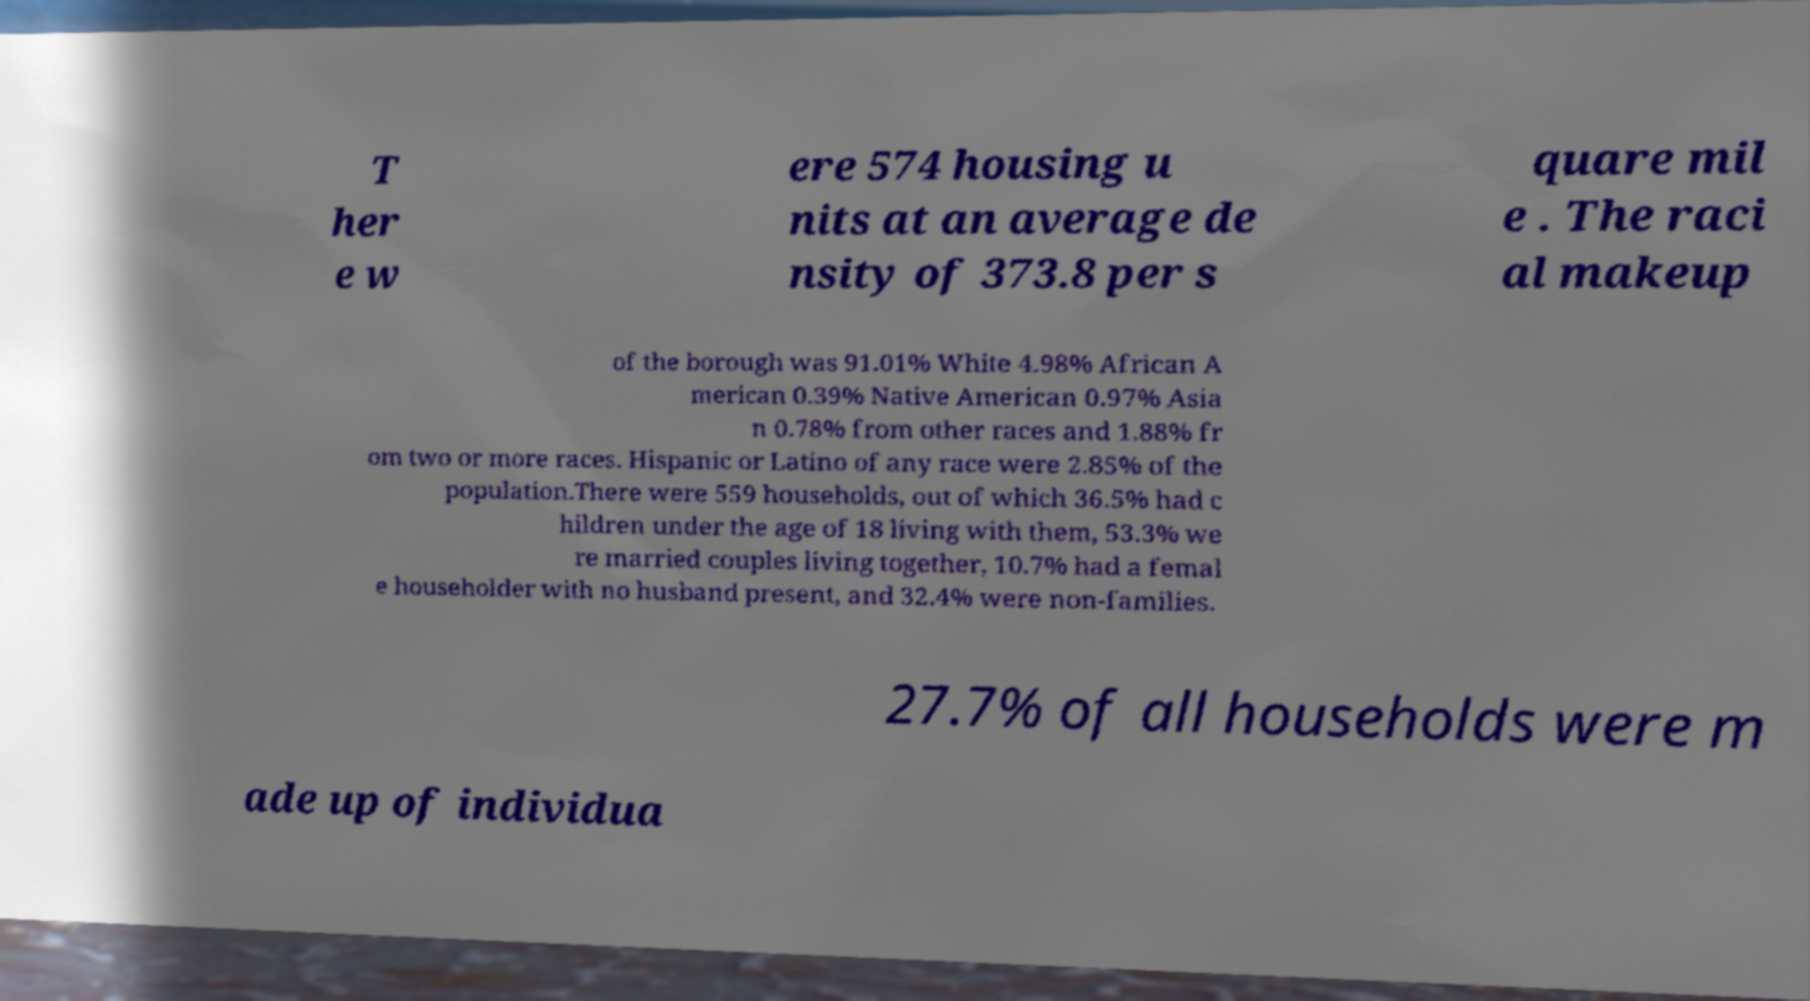Could you assist in decoding the text presented in this image and type it out clearly? T her e w ere 574 housing u nits at an average de nsity of 373.8 per s quare mil e . The raci al makeup of the borough was 91.01% White 4.98% African A merican 0.39% Native American 0.97% Asia n 0.78% from other races and 1.88% fr om two or more races. Hispanic or Latino of any race were 2.85% of the population.There were 559 households, out of which 36.5% had c hildren under the age of 18 living with them, 53.3% we re married couples living together, 10.7% had a femal e householder with no husband present, and 32.4% were non-families. 27.7% of all households were m ade up of individua 